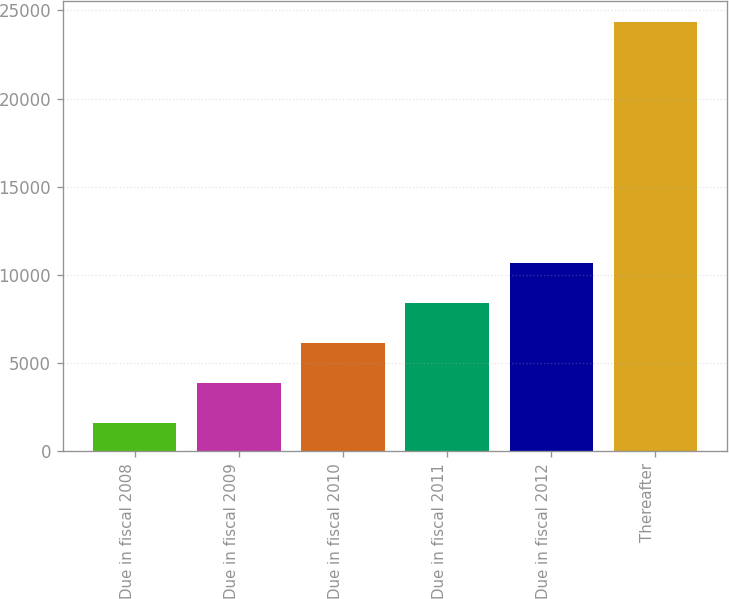<chart> <loc_0><loc_0><loc_500><loc_500><bar_chart><fcel>Due in fiscal 2008<fcel>Due in fiscal 2009<fcel>Due in fiscal 2010<fcel>Due in fiscal 2011<fcel>Due in fiscal 2012<fcel>Thereafter<nl><fcel>1592<fcel>3866.5<fcel>6141<fcel>8415.5<fcel>10690<fcel>24337<nl></chart> 